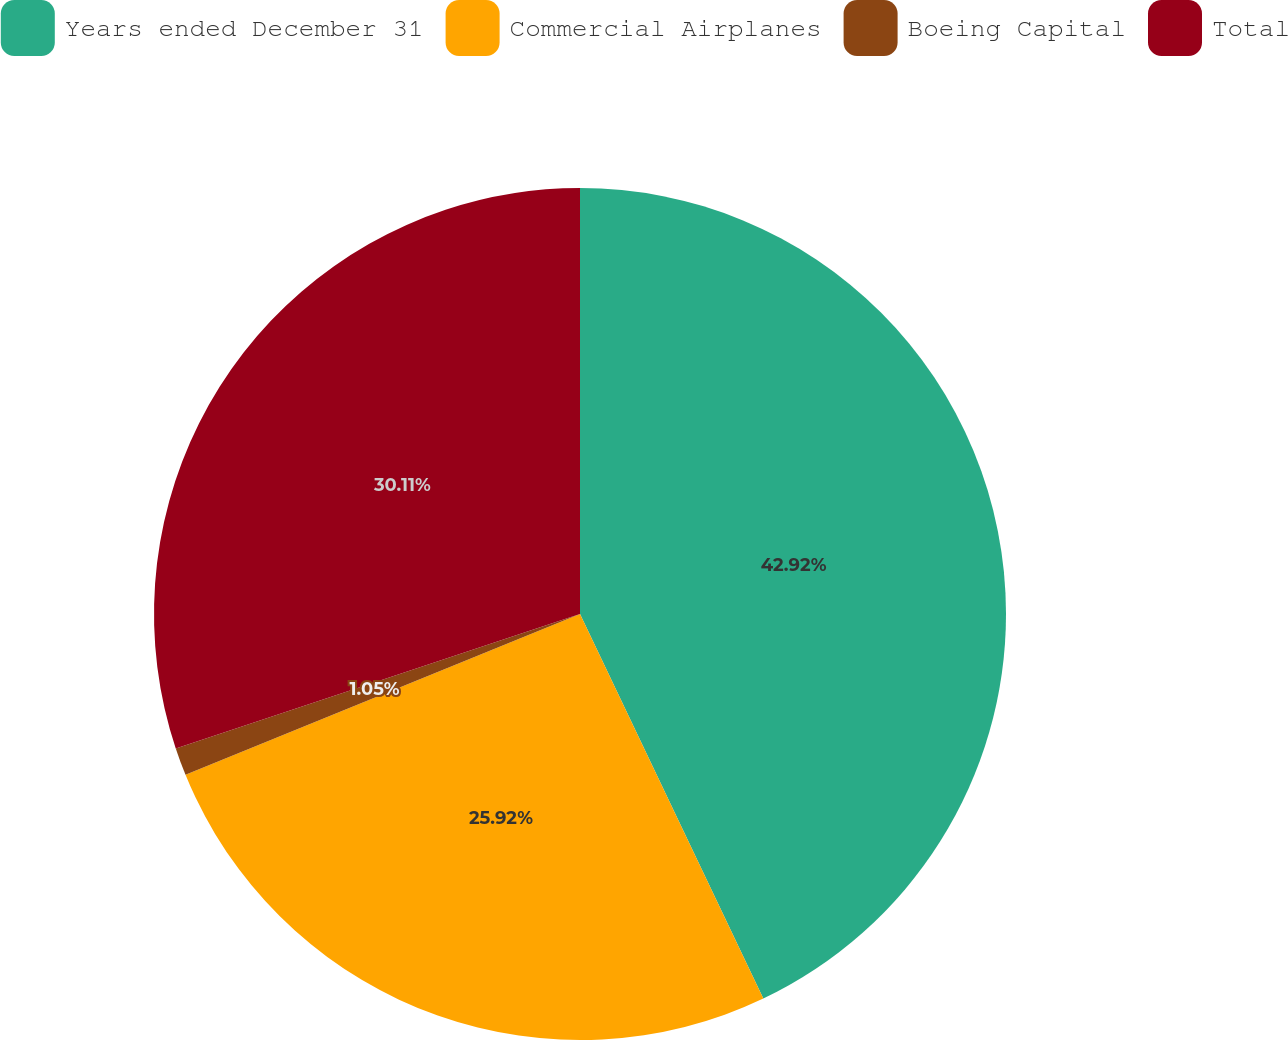Convert chart to OTSL. <chart><loc_0><loc_0><loc_500><loc_500><pie_chart><fcel>Years ended December 31<fcel>Commercial Airplanes<fcel>Boeing Capital<fcel>Total<nl><fcel>42.92%<fcel>25.92%<fcel>1.05%<fcel>30.11%<nl></chart> 